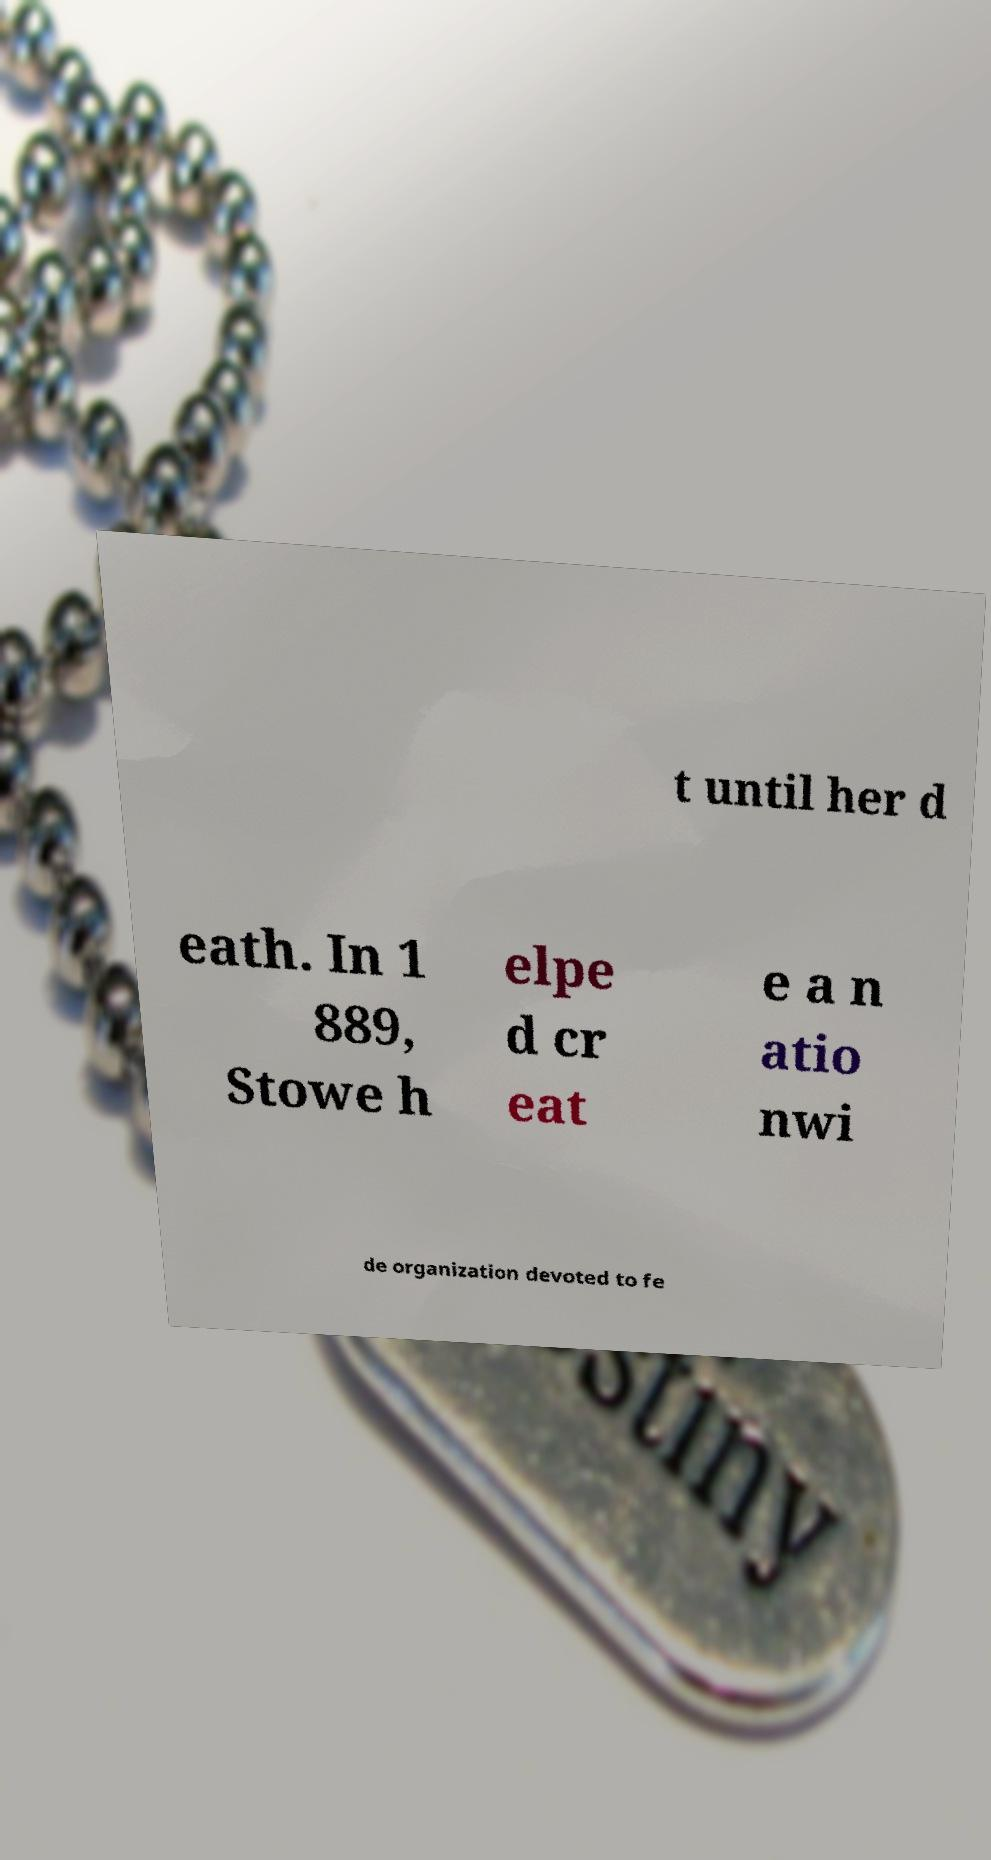Please identify and transcribe the text found in this image. t until her d eath. In 1 889, Stowe h elpe d cr eat e a n atio nwi de organization devoted to fe 